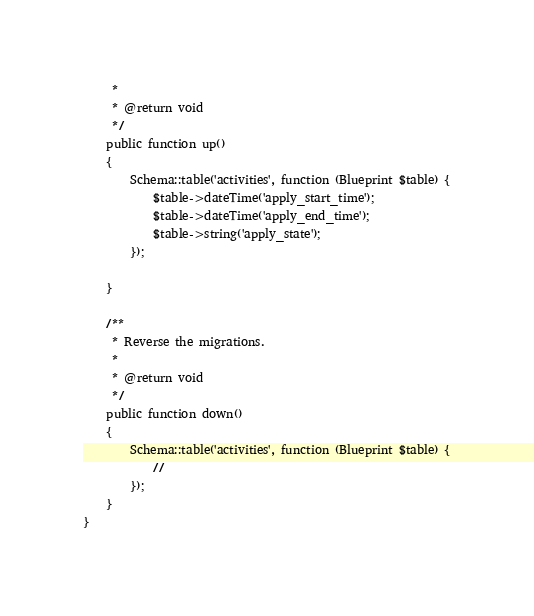<code> <loc_0><loc_0><loc_500><loc_500><_PHP_>     *
     * @return void
     */
    public function up()
    {
        Schema::table('activities', function (Blueprint $table) {
            $table->dateTime('apply_start_time');
            $table->dateTime('apply_end_time');
            $table->string('apply_state');
        });

    }

    /**
     * Reverse the migrations.
     *
     * @return void
     */
    public function down()
    {
        Schema::table('activities', function (Blueprint $table) {
            //
        });
    }
}
</code> 